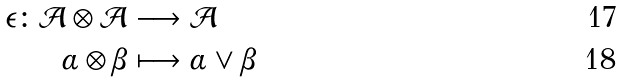Convert formula to latex. <formula><loc_0><loc_0><loc_500><loc_500>\epsilon \colon \mathcal { A } \otimes \mathcal { A } & \longrightarrow \mathcal { A } \\ \alpha \otimes \beta & \longmapsto \alpha \vee \beta</formula> 